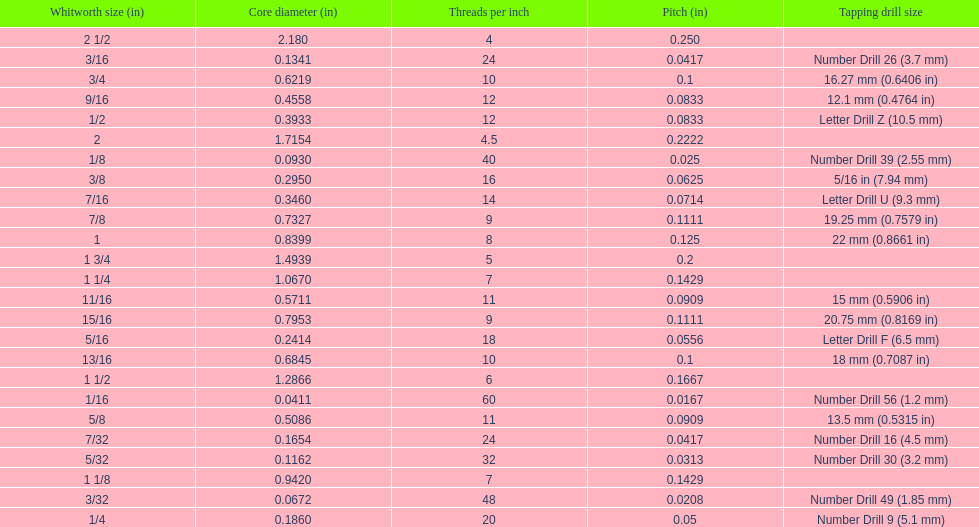What is the least core diameter (in)? 0.0411. 